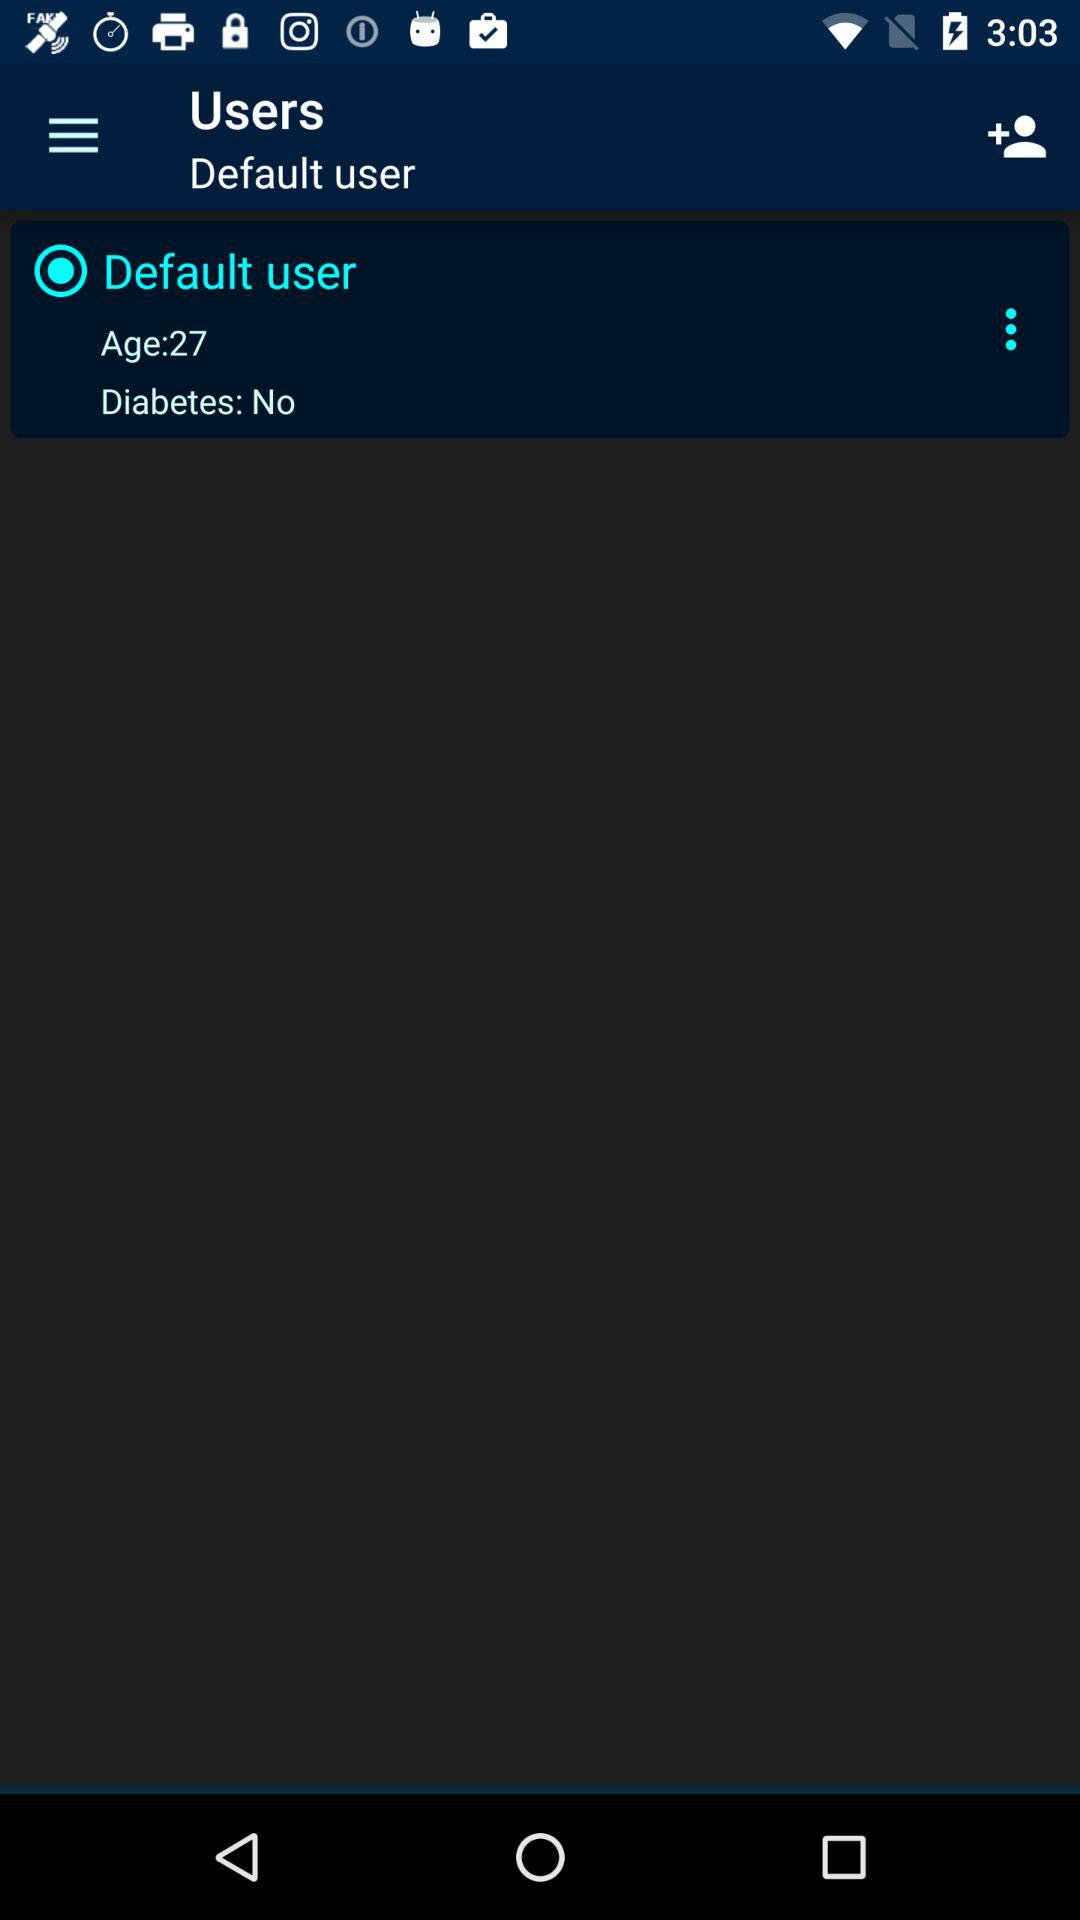What is the age of the selected user? The age of the selected user is 27. 